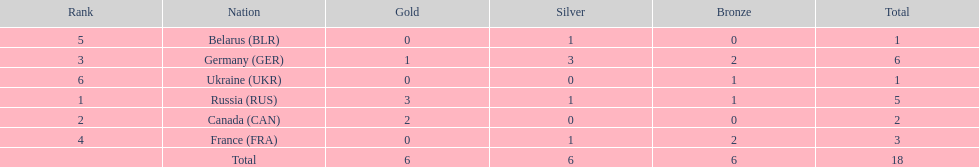What were the only 3 countries to win gold medals at the the 1994 winter olympics biathlon? Russia (RUS), Canada (CAN), Germany (GER). 